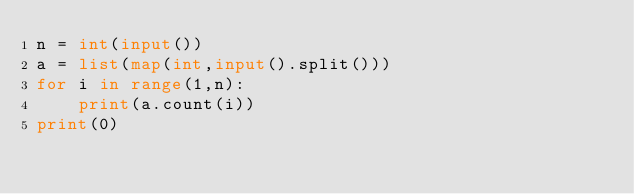Convert code to text. <code><loc_0><loc_0><loc_500><loc_500><_Python_>n = int(input())
a = list(map(int,input().split()))
for i in range(1,n):
    print(a.count(i))
print(0)</code> 